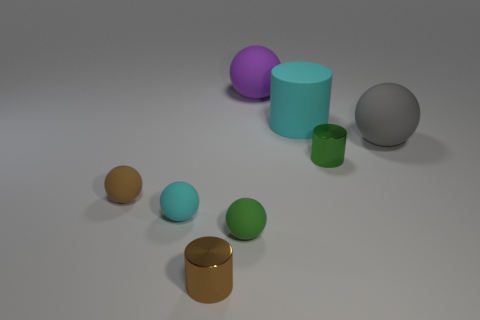Subtract 1 spheres. How many spheres are left? 4 Subtract all green balls. How many balls are left? 4 Subtract all brown balls. How many balls are left? 4 Subtract all blue spheres. Subtract all yellow cubes. How many spheres are left? 5 Add 1 big green matte spheres. How many objects exist? 9 Subtract all cylinders. How many objects are left? 5 Subtract 1 brown cylinders. How many objects are left? 7 Subtract all big things. Subtract all gray rubber things. How many objects are left? 4 Add 6 small rubber spheres. How many small rubber spheres are left? 9 Add 8 yellow metallic balls. How many yellow metallic balls exist? 8 